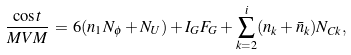Convert formula to latex. <formula><loc_0><loc_0><loc_500><loc_500>\frac { \cos t } { M V M } \, = \, 6 ( n _ { 1 } N _ { \phi } + N _ { U } ) + I _ { G } F _ { G } + \sum _ { k = 2 } ^ { i } ( n _ { k } + \bar { n } _ { k } ) N _ { C k } ,</formula> 